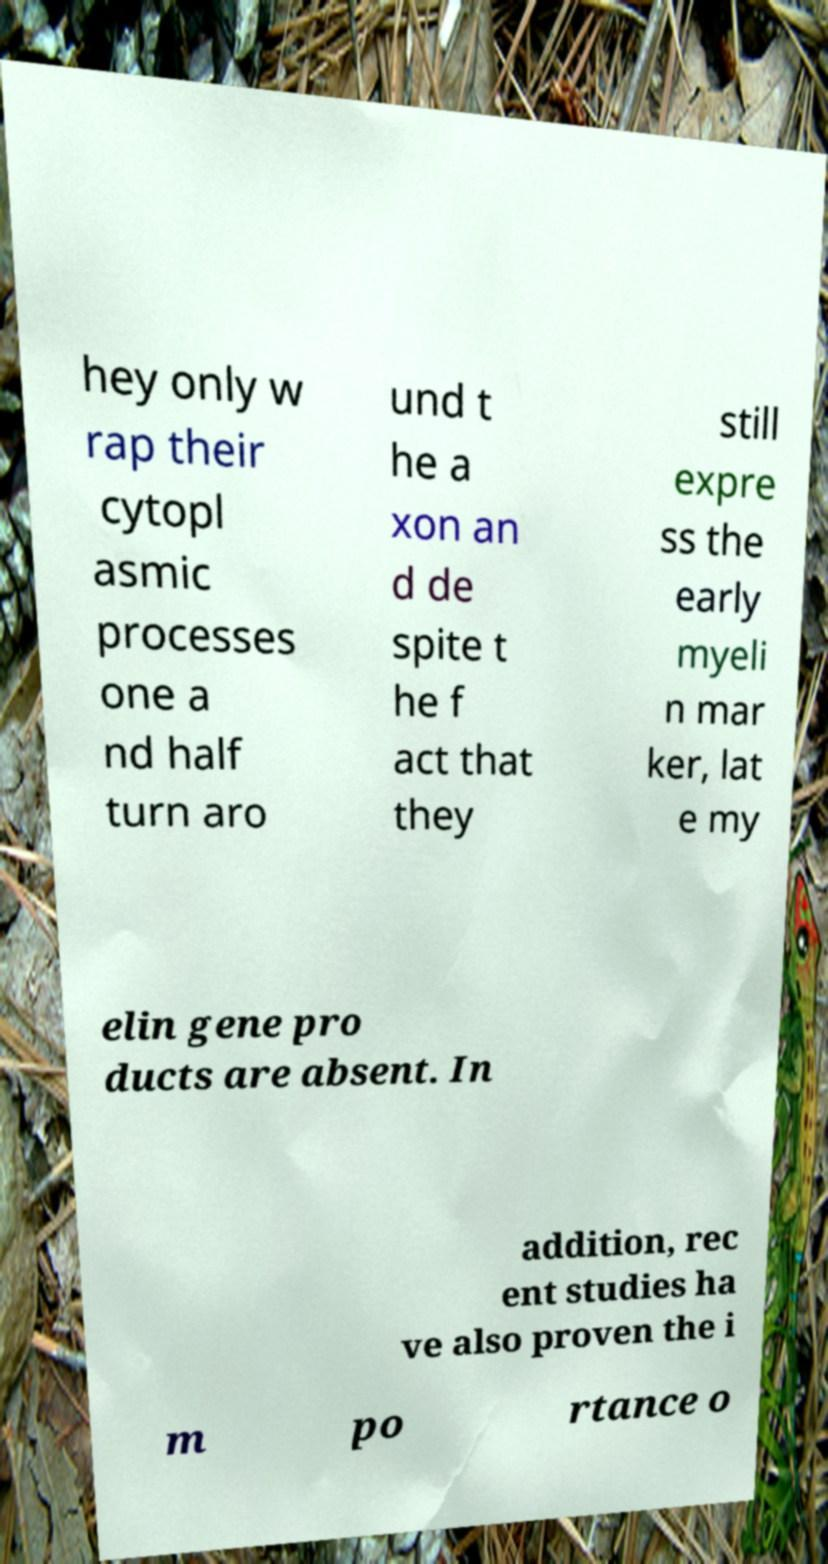Could you assist in decoding the text presented in this image and type it out clearly? hey only w rap their cytopl asmic processes one a nd half turn aro und t he a xon an d de spite t he f act that they still expre ss the early myeli n mar ker, lat e my elin gene pro ducts are absent. In addition, rec ent studies ha ve also proven the i m po rtance o 